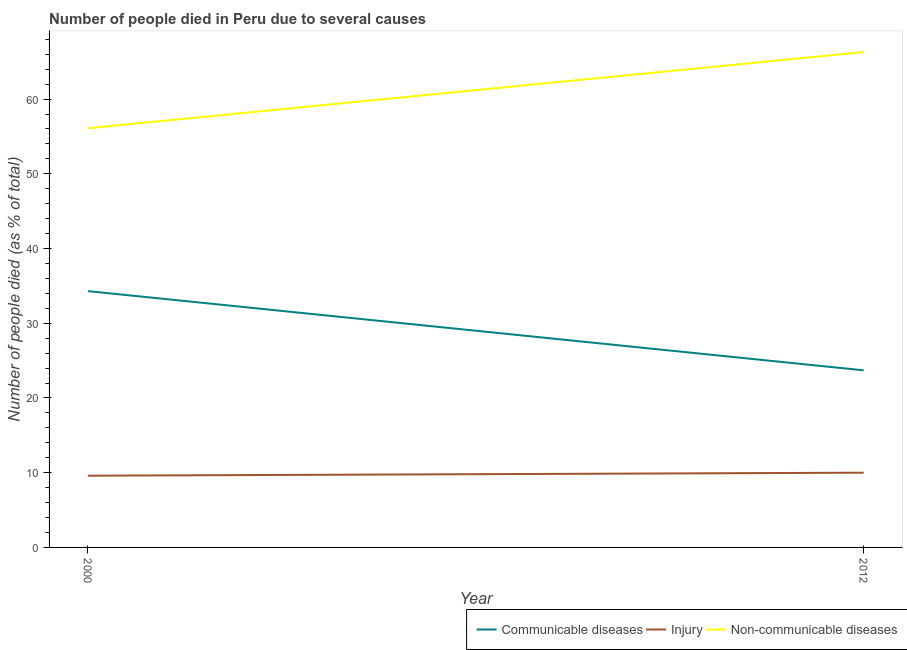Does the line corresponding to number of people who dies of non-communicable diseases intersect with the line corresponding to number of people who died of injury?
Offer a very short reply. No. Is the number of lines equal to the number of legend labels?
Ensure brevity in your answer.  Yes. What is the number of people who died of injury in 2012?
Your response must be concise. 10. Across all years, what is the maximum number of people who died of communicable diseases?
Make the answer very short. 34.3. Across all years, what is the minimum number of people who died of communicable diseases?
Ensure brevity in your answer.  23.7. In which year was the number of people who died of communicable diseases maximum?
Your response must be concise. 2000. What is the total number of people who died of injury in the graph?
Your answer should be compact. 19.6. What is the difference between the number of people who died of injury in 2000 and that in 2012?
Your answer should be very brief. -0.4. What is the difference between the number of people who died of injury in 2012 and the number of people who dies of non-communicable diseases in 2000?
Offer a very short reply. -46.1. In the year 2000, what is the difference between the number of people who died of injury and number of people who died of communicable diseases?
Your answer should be very brief. -24.7. What is the ratio of the number of people who died of injury in 2000 to that in 2012?
Ensure brevity in your answer.  0.96. Is the number of people who died of communicable diseases in 2000 less than that in 2012?
Your answer should be very brief. No. In how many years, is the number of people who died of injury greater than the average number of people who died of injury taken over all years?
Offer a very short reply. 1. Does the number of people who dies of non-communicable diseases monotonically increase over the years?
Your response must be concise. Yes. How many lines are there?
Ensure brevity in your answer.  3. What is the difference between two consecutive major ticks on the Y-axis?
Give a very brief answer. 10. Are the values on the major ticks of Y-axis written in scientific E-notation?
Your response must be concise. No. How many legend labels are there?
Give a very brief answer. 3. How are the legend labels stacked?
Provide a short and direct response. Horizontal. What is the title of the graph?
Ensure brevity in your answer.  Number of people died in Peru due to several causes. What is the label or title of the Y-axis?
Give a very brief answer. Number of people died (as % of total). What is the Number of people died (as % of total) in Communicable diseases in 2000?
Ensure brevity in your answer.  34.3. What is the Number of people died (as % of total) of Non-communicable diseases in 2000?
Offer a very short reply. 56.1. What is the Number of people died (as % of total) of Communicable diseases in 2012?
Your response must be concise. 23.7. What is the Number of people died (as % of total) of Injury in 2012?
Ensure brevity in your answer.  10. What is the Number of people died (as % of total) in Non-communicable diseases in 2012?
Provide a succinct answer. 66.3. Across all years, what is the maximum Number of people died (as % of total) in Communicable diseases?
Offer a very short reply. 34.3. Across all years, what is the maximum Number of people died (as % of total) in Non-communicable diseases?
Your answer should be compact. 66.3. Across all years, what is the minimum Number of people died (as % of total) in Communicable diseases?
Your answer should be compact. 23.7. Across all years, what is the minimum Number of people died (as % of total) of Non-communicable diseases?
Provide a succinct answer. 56.1. What is the total Number of people died (as % of total) of Injury in the graph?
Ensure brevity in your answer.  19.6. What is the total Number of people died (as % of total) of Non-communicable diseases in the graph?
Provide a succinct answer. 122.4. What is the difference between the Number of people died (as % of total) in Communicable diseases in 2000 and that in 2012?
Provide a short and direct response. 10.6. What is the difference between the Number of people died (as % of total) of Injury in 2000 and that in 2012?
Make the answer very short. -0.4. What is the difference between the Number of people died (as % of total) of Non-communicable diseases in 2000 and that in 2012?
Give a very brief answer. -10.2. What is the difference between the Number of people died (as % of total) of Communicable diseases in 2000 and the Number of people died (as % of total) of Injury in 2012?
Your response must be concise. 24.3. What is the difference between the Number of people died (as % of total) of Communicable diseases in 2000 and the Number of people died (as % of total) of Non-communicable diseases in 2012?
Your answer should be compact. -32. What is the difference between the Number of people died (as % of total) of Injury in 2000 and the Number of people died (as % of total) of Non-communicable diseases in 2012?
Ensure brevity in your answer.  -56.7. What is the average Number of people died (as % of total) in Communicable diseases per year?
Make the answer very short. 29. What is the average Number of people died (as % of total) in Non-communicable diseases per year?
Ensure brevity in your answer.  61.2. In the year 2000, what is the difference between the Number of people died (as % of total) in Communicable diseases and Number of people died (as % of total) in Injury?
Provide a short and direct response. 24.7. In the year 2000, what is the difference between the Number of people died (as % of total) in Communicable diseases and Number of people died (as % of total) in Non-communicable diseases?
Offer a terse response. -21.8. In the year 2000, what is the difference between the Number of people died (as % of total) in Injury and Number of people died (as % of total) in Non-communicable diseases?
Offer a very short reply. -46.5. In the year 2012, what is the difference between the Number of people died (as % of total) of Communicable diseases and Number of people died (as % of total) of Injury?
Offer a terse response. 13.7. In the year 2012, what is the difference between the Number of people died (as % of total) of Communicable diseases and Number of people died (as % of total) of Non-communicable diseases?
Provide a short and direct response. -42.6. In the year 2012, what is the difference between the Number of people died (as % of total) of Injury and Number of people died (as % of total) of Non-communicable diseases?
Your answer should be very brief. -56.3. What is the ratio of the Number of people died (as % of total) in Communicable diseases in 2000 to that in 2012?
Keep it short and to the point. 1.45. What is the ratio of the Number of people died (as % of total) in Non-communicable diseases in 2000 to that in 2012?
Make the answer very short. 0.85. What is the difference between the highest and the lowest Number of people died (as % of total) in Injury?
Your response must be concise. 0.4. 